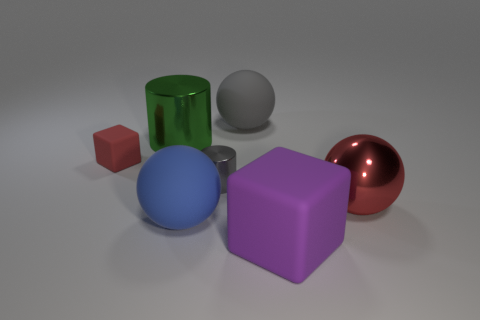Subtract all big red shiny spheres. How many spheres are left? 2 Add 3 brown balls. How many objects exist? 10 Subtract all balls. How many objects are left? 4 Subtract 2 cylinders. How many cylinders are left? 0 Subtract all gray balls. How many balls are left? 2 Subtract 0 cyan balls. How many objects are left? 7 Subtract all green balls. Subtract all gray blocks. How many balls are left? 3 Subtract all big shiny cylinders. Subtract all big rubber cubes. How many objects are left? 5 Add 2 big blue rubber objects. How many big blue rubber objects are left? 3 Add 2 small rubber things. How many small rubber things exist? 3 